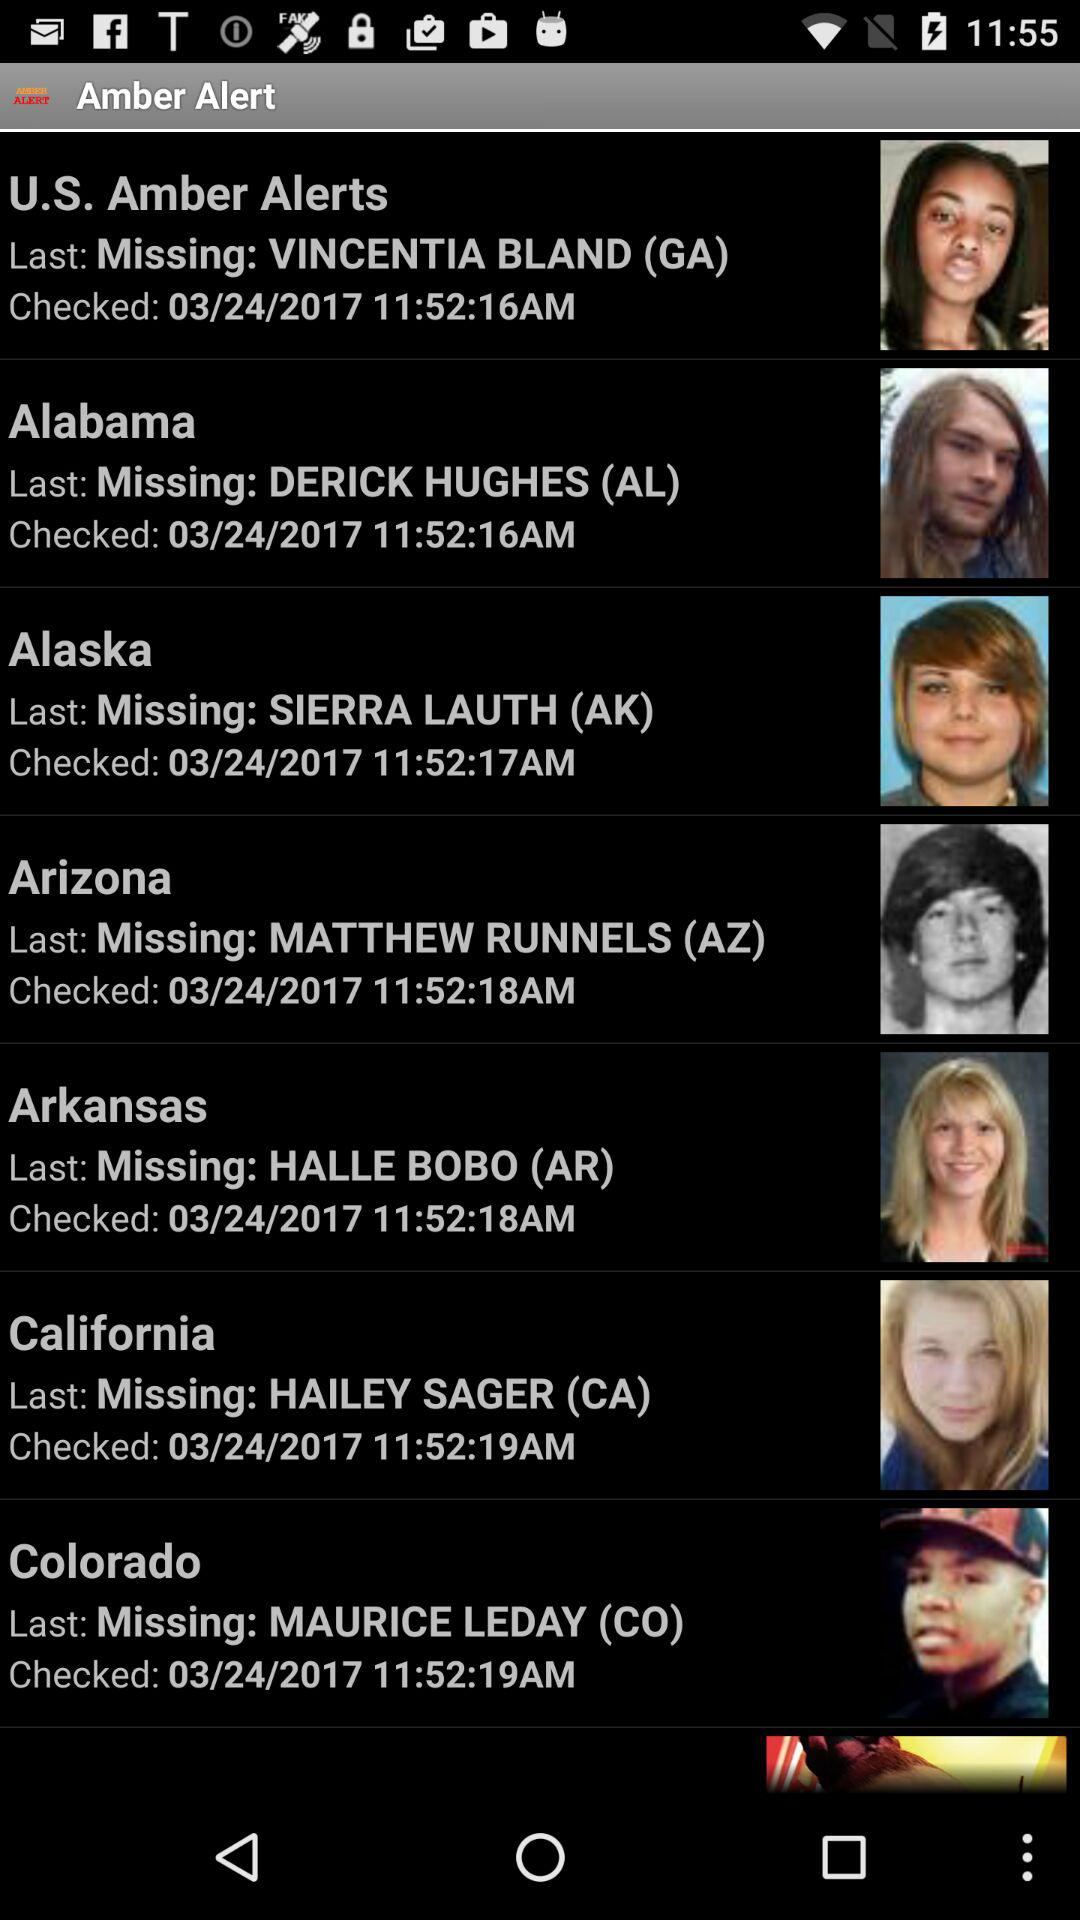What is the checked date of the amber alert for Maurice Leday? The checked date is March 24, 2017. 